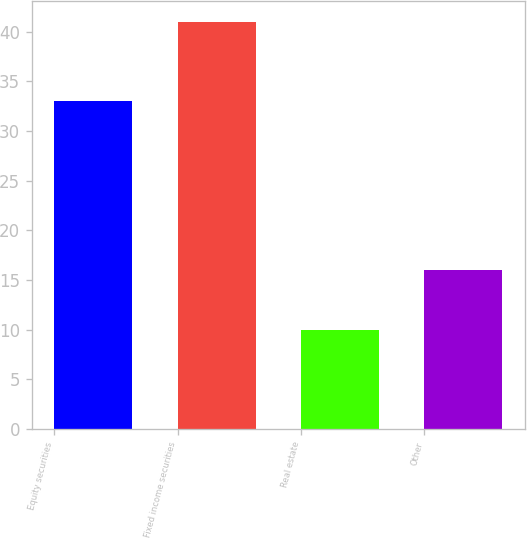Convert chart. <chart><loc_0><loc_0><loc_500><loc_500><bar_chart><fcel>Equity securities<fcel>Fixed income securities<fcel>Real estate<fcel>Other<nl><fcel>33<fcel>41<fcel>10<fcel>16<nl></chart> 